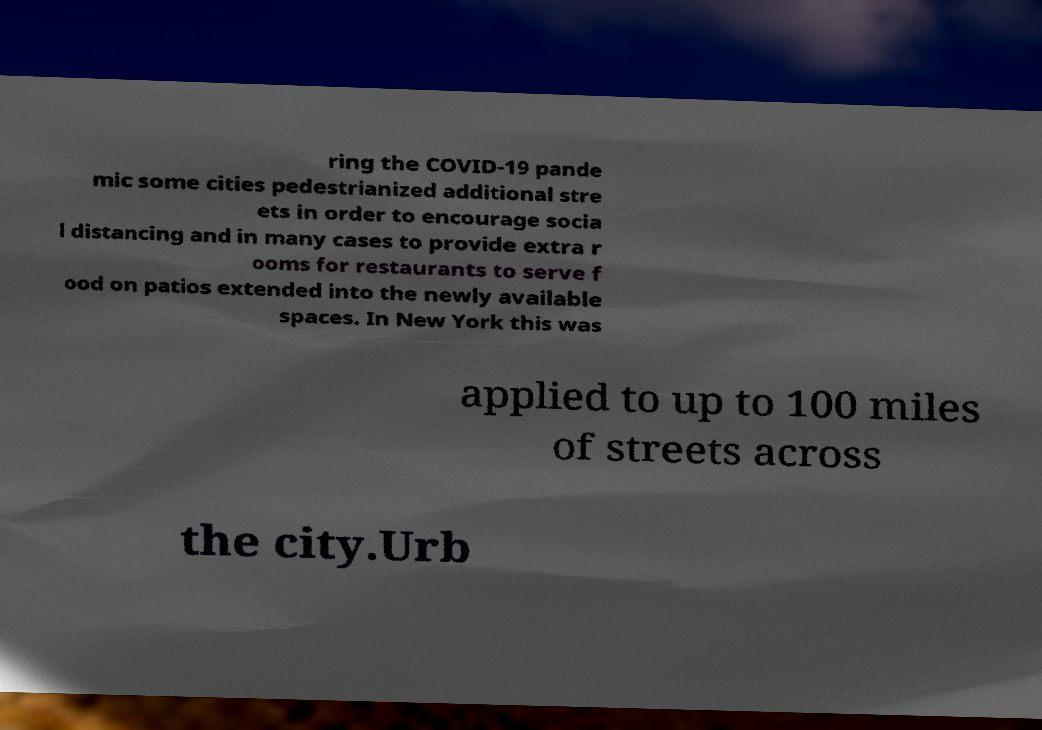There's text embedded in this image that I need extracted. Can you transcribe it verbatim? ring the COVID-19 pande mic some cities pedestrianized additional stre ets in order to encourage socia l distancing and in many cases to provide extra r ooms for restaurants to serve f ood on patios extended into the newly available spaces. In New York this was applied to up to 100 miles of streets across the city.Urb 